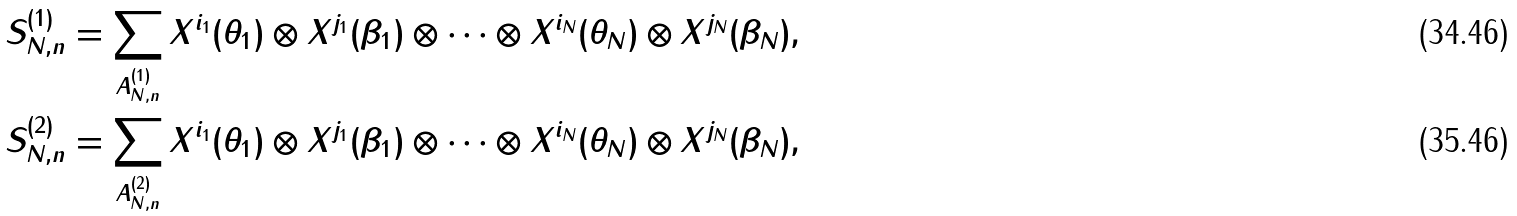Convert formula to latex. <formula><loc_0><loc_0><loc_500><loc_500>S _ { N , n } ^ { ( 1 ) } = \sum _ { A _ { N , n } ^ { ( 1 ) } } X ^ { i _ { 1 } } ( \theta _ { 1 } ) \otimes X ^ { j _ { 1 } } ( \beta _ { 1 } ) \otimes \cdots \otimes X ^ { i _ { N } } ( \theta _ { N } ) \otimes X ^ { j _ { N } } ( \beta _ { N } ) , \\ S _ { N , n } ^ { ( 2 ) } = \sum _ { A _ { N , n } ^ { ( 2 ) } } X ^ { i _ { 1 } } ( \theta _ { 1 } ) \otimes X ^ { j _ { 1 } } ( \beta _ { 1 } ) \otimes \cdots \otimes X ^ { i _ { N } } ( \theta _ { N } ) \otimes X ^ { j _ { N } } ( \beta _ { N } ) ,</formula> 